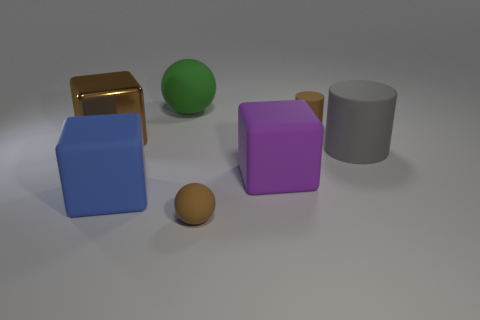Add 2 tiny yellow shiny cylinders. How many objects exist? 9 Subtract all blocks. How many objects are left? 4 Add 6 small cylinders. How many small cylinders are left? 7 Add 2 rubber things. How many rubber things exist? 8 Subtract 0 red blocks. How many objects are left? 7 Subtract all purple metal spheres. Subtract all small things. How many objects are left? 5 